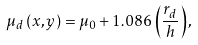<formula> <loc_0><loc_0><loc_500><loc_500>\mu _ { d } \left ( x , y \right ) = \mu _ { 0 } + 1 . 0 8 6 \left ( \frac { r _ { d } } { h } \right ) ,</formula> 